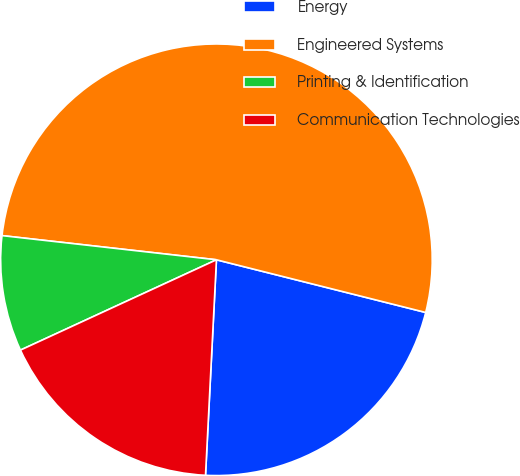<chart> <loc_0><loc_0><loc_500><loc_500><pie_chart><fcel>Energy<fcel>Engineered Systems<fcel>Printing & Identification<fcel>Communication Technologies<nl><fcel>21.88%<fcel>52.14%<fcel>8.66%<fcel>17.32%<nl></chart> 